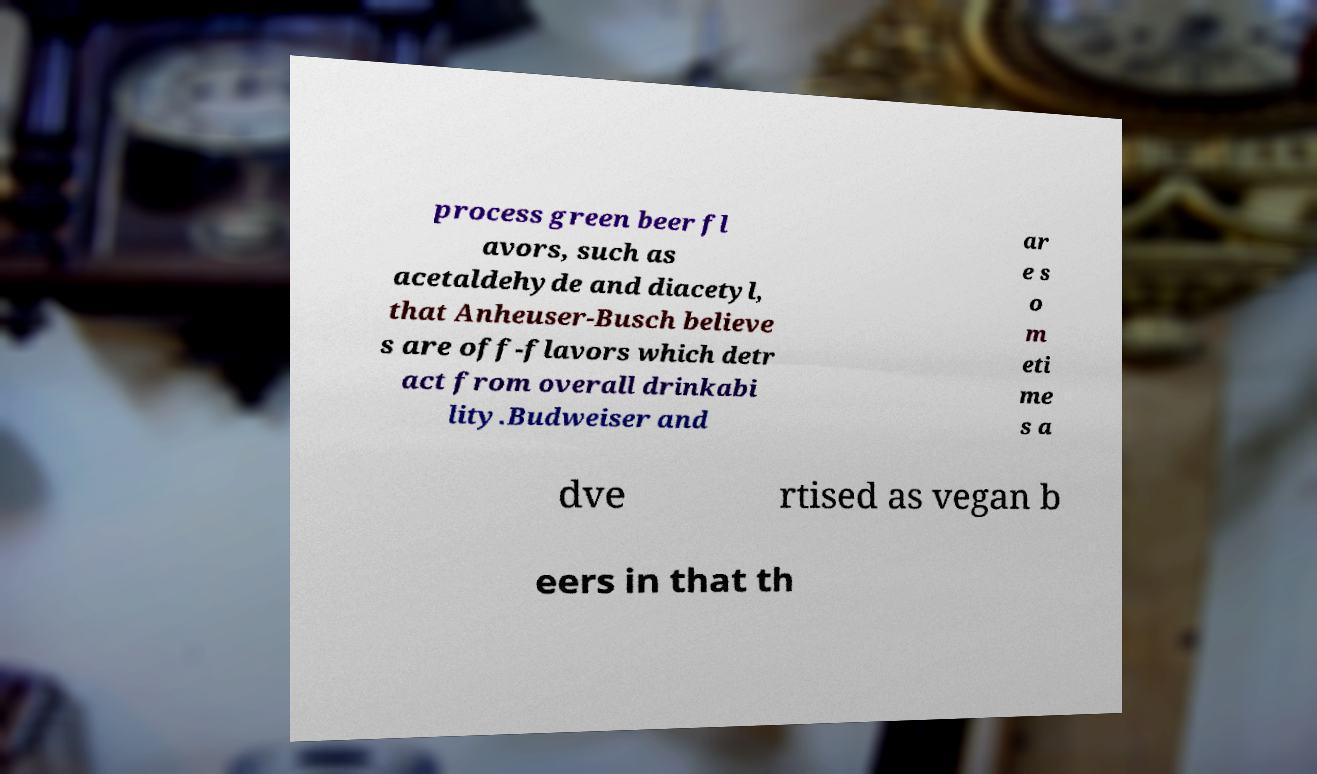For documentation purposes, I need the text within this image transcribed. Could you provide that? process green beer fl avors, such as acetaldehyde and diacetyl, that Anheuser-Busch believe s are off-flavors which detr act from overall drinkabi lity.Budweiser and ar e s o m eti me s a dve rtised as vegan b eers in that th 